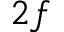<formula> <loc_0><loc_0><loc_500><loc_500>2 f</formula> 